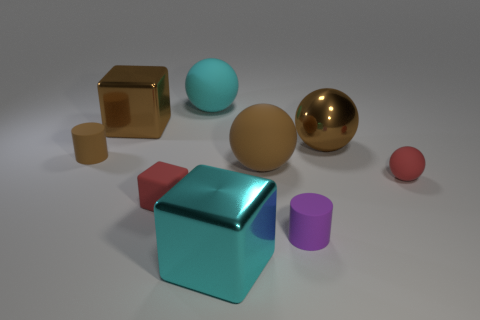Subtract all big metal blocks. How many blocks are left? 1 Add 1 red cubes. How many objects exist? 10 Subtract all cyan spheres. How many spheres are left? 3 Subtract all purple cylinders. How many brown balls are left? 2 Subtract 1 spheres. How many spheres are left? 3 Subtract 1 brown balls. How many objects are left? 8 Subtract all balls. How many objects are left? 5 Subtract all red blocks. Subtract all blue balls. How many blocks are left? 2 Subtract all large blue cylinders. Subtract all small brown rubber cylinders. How many objects are left? 8 Add 3 large metallic spheres. How many large metallic spheres are left? 4 